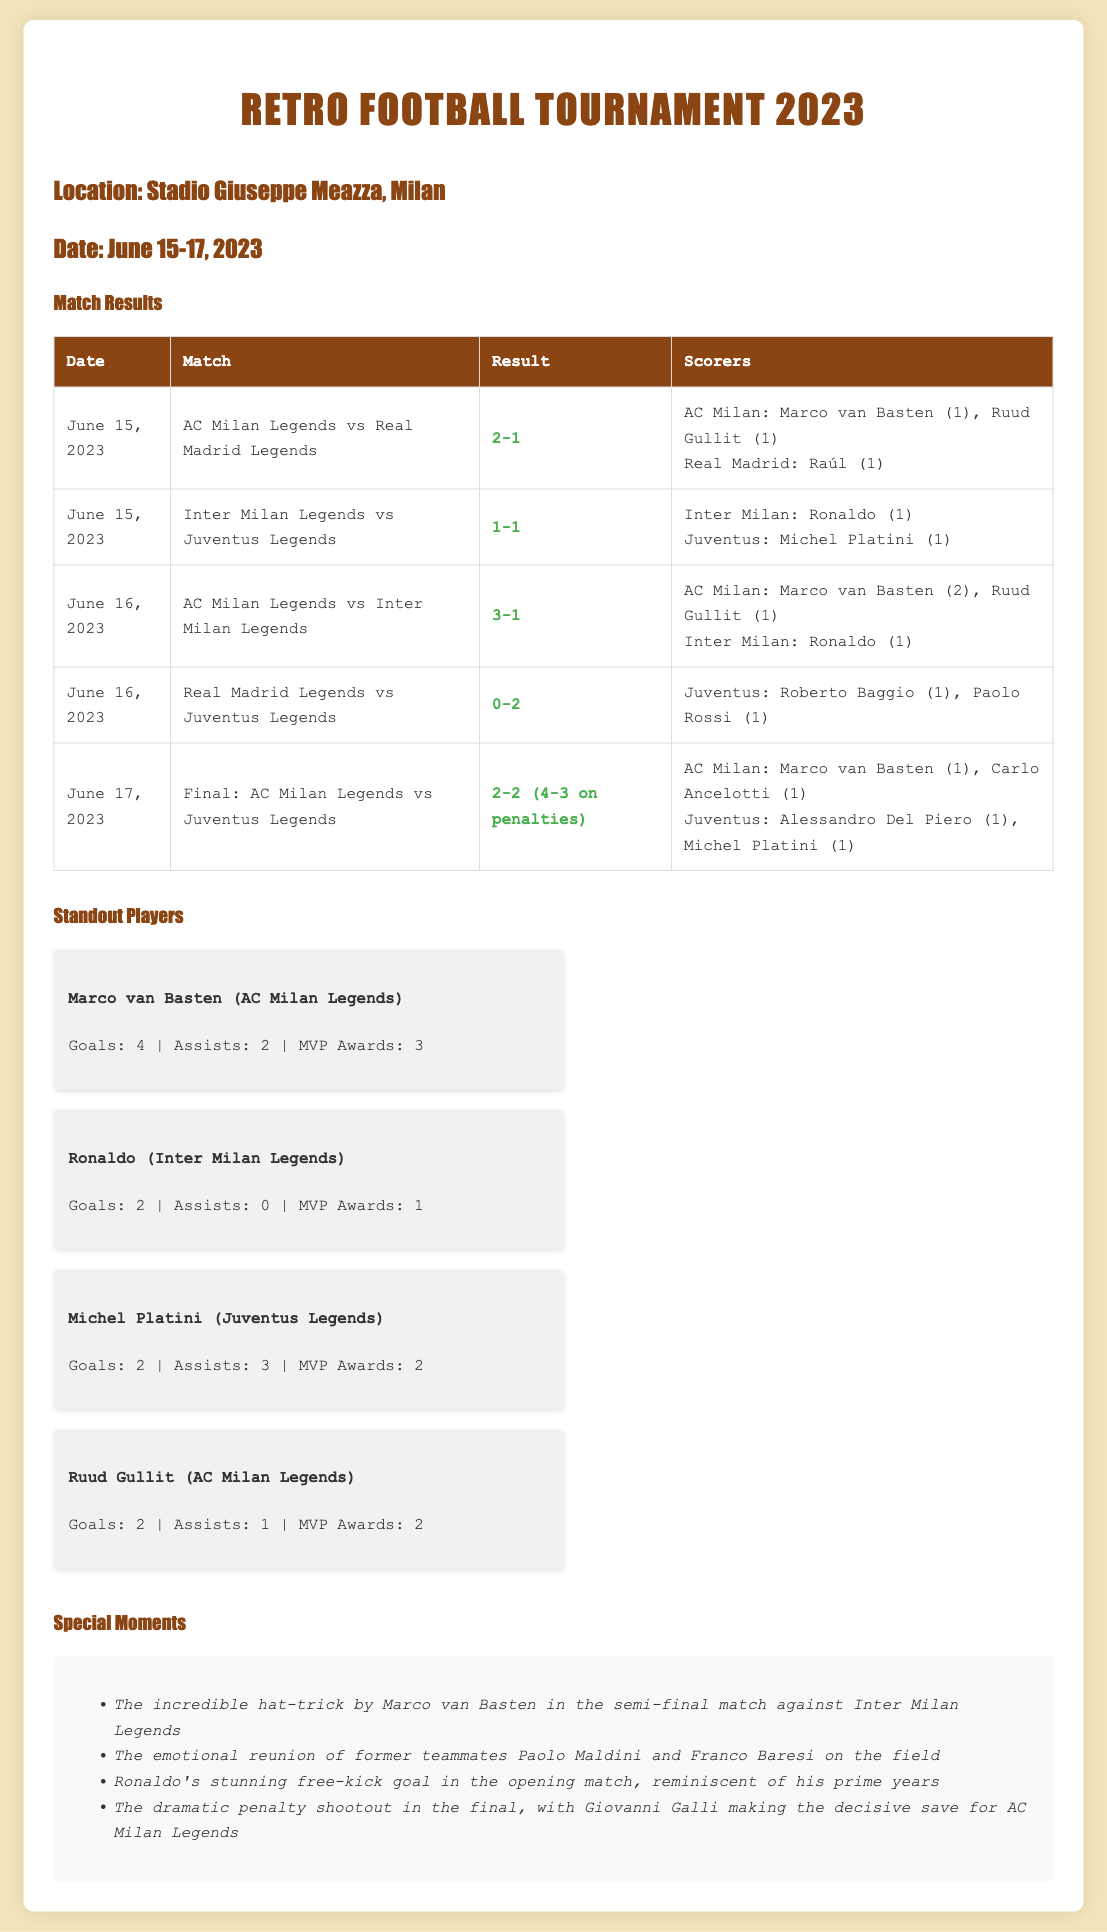What was the location of the tournament? The document specifies that the tournament was held at Stadio Giuseppe Meazza, Milan.
Answer: Stadio Giuseppe Meazza, Milan What were the dates of the tournament? The tournament took place from June 15 to June 17, 2023.
Answer: June 15-17, 2023 Who won the final match? The final match between AC Milan Legends and Juventus Legends ended with a penalty shootout, which AC Milan won.
Answer: AC Milan Legends How many goals did Marco van Basten score in the tournament? The standout player stats indicate Marco van Basten scored a total of 4 goals.
Answer: 4 Which player had the most MVP awards? The standout players section shows that Marco van Basten had the highest number of MVP awards with 3.
Answer: Marco van Basten What was the result of the match between AC Milan Legends and Inter Milan Legends? The match result is detailed in the match results table, indicating a score of 3-1 in favor of AC Milan.
Answer: 3-1 Who scored the stunning free-kick goal? The special moments section mentions that Ronaldo scored the stunning free-kick goal.
Answer: Ronaldo How many goals did Juventus score in the final match? The match results state that Juventus scored a total of 2 goals in the final match.
Answer: 2 What was the match result between Real Madrid Legends and Juventus Legends? The table indicates that Juventus won the match against Real Madrid with a score of 2-0.
Answer: 2-0 